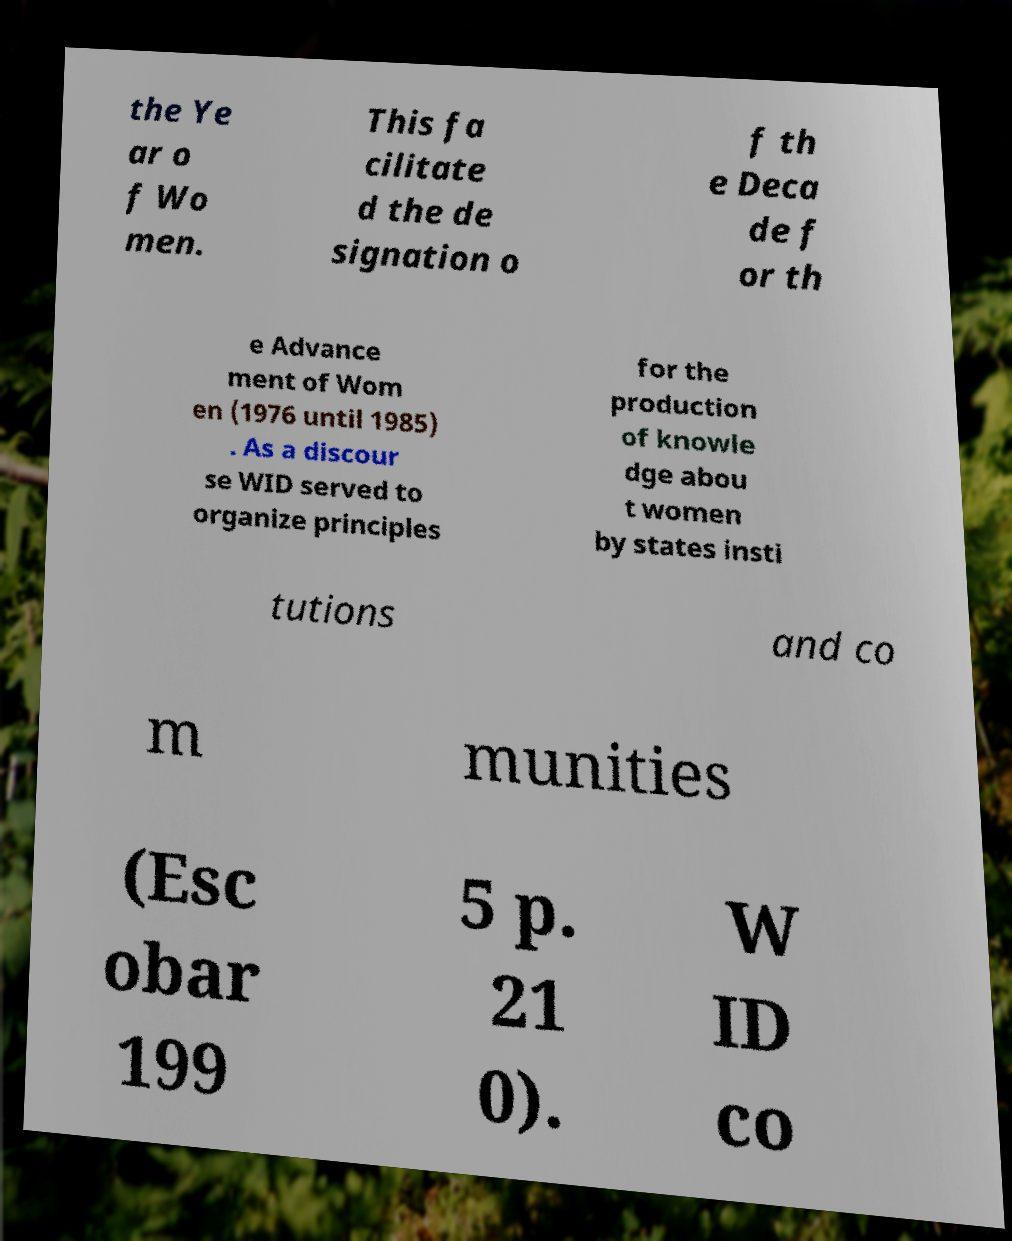I need the written content from this picture converted into text. Can you do that? the Ye ar o f Wo men. This fa cilitate d the de signation o f th e Deca de f or th e Advance ment of Wom en (1976 until 1985) . As a discour se WID served to organize principles for the production of knowle dge abou t women by states insti tutions and co m munities (Esc obar 199 5 p. 21 0). W ID co 